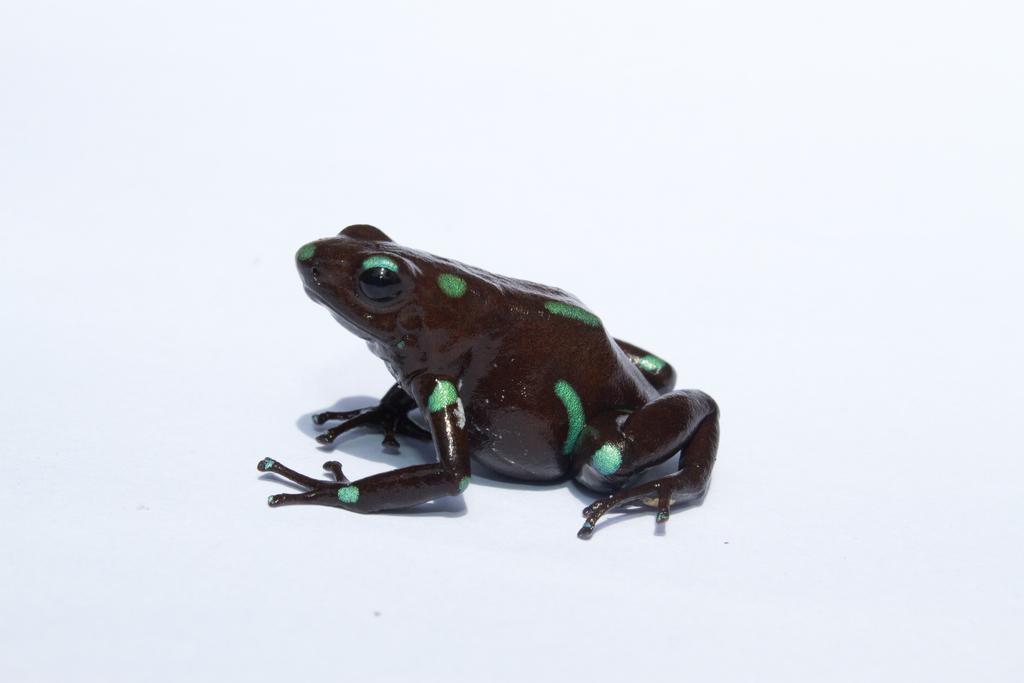Could you give a brief overview of what you see in this image? In this picture we can see a green and black color frog setting in the front. Behind there is a white background. 